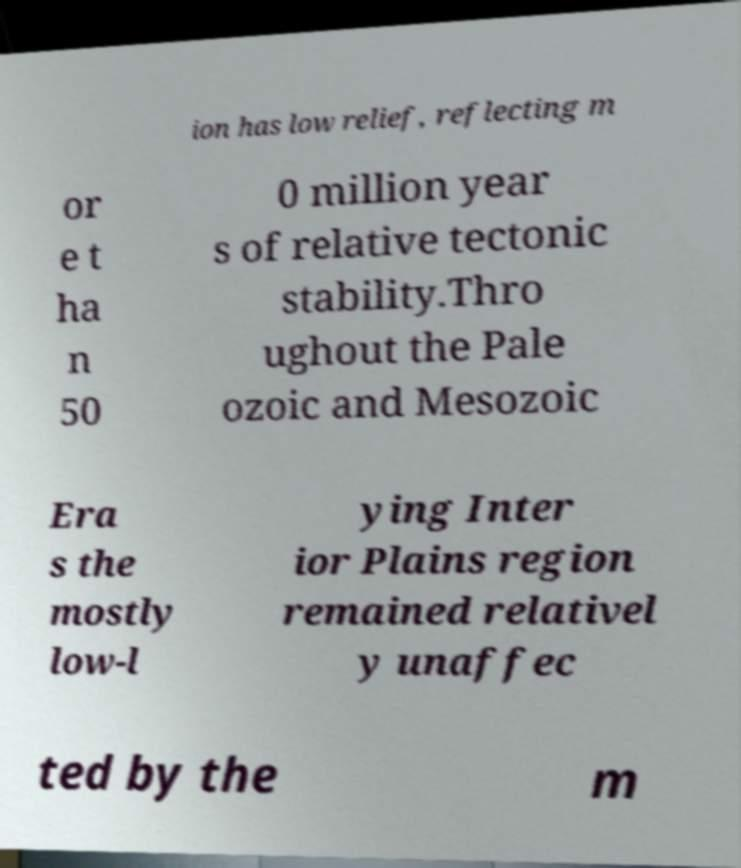Please identify and transcribe the text found in this image. ion has low relief, reflecting m or e t ha n 50 0 million year s of relative tectonic stability.Thro ughout the Pale ozoic and Mesozoic Era s the mostly low-l ying Inter ior Plains region remained relativel y unaffec ted by the m 